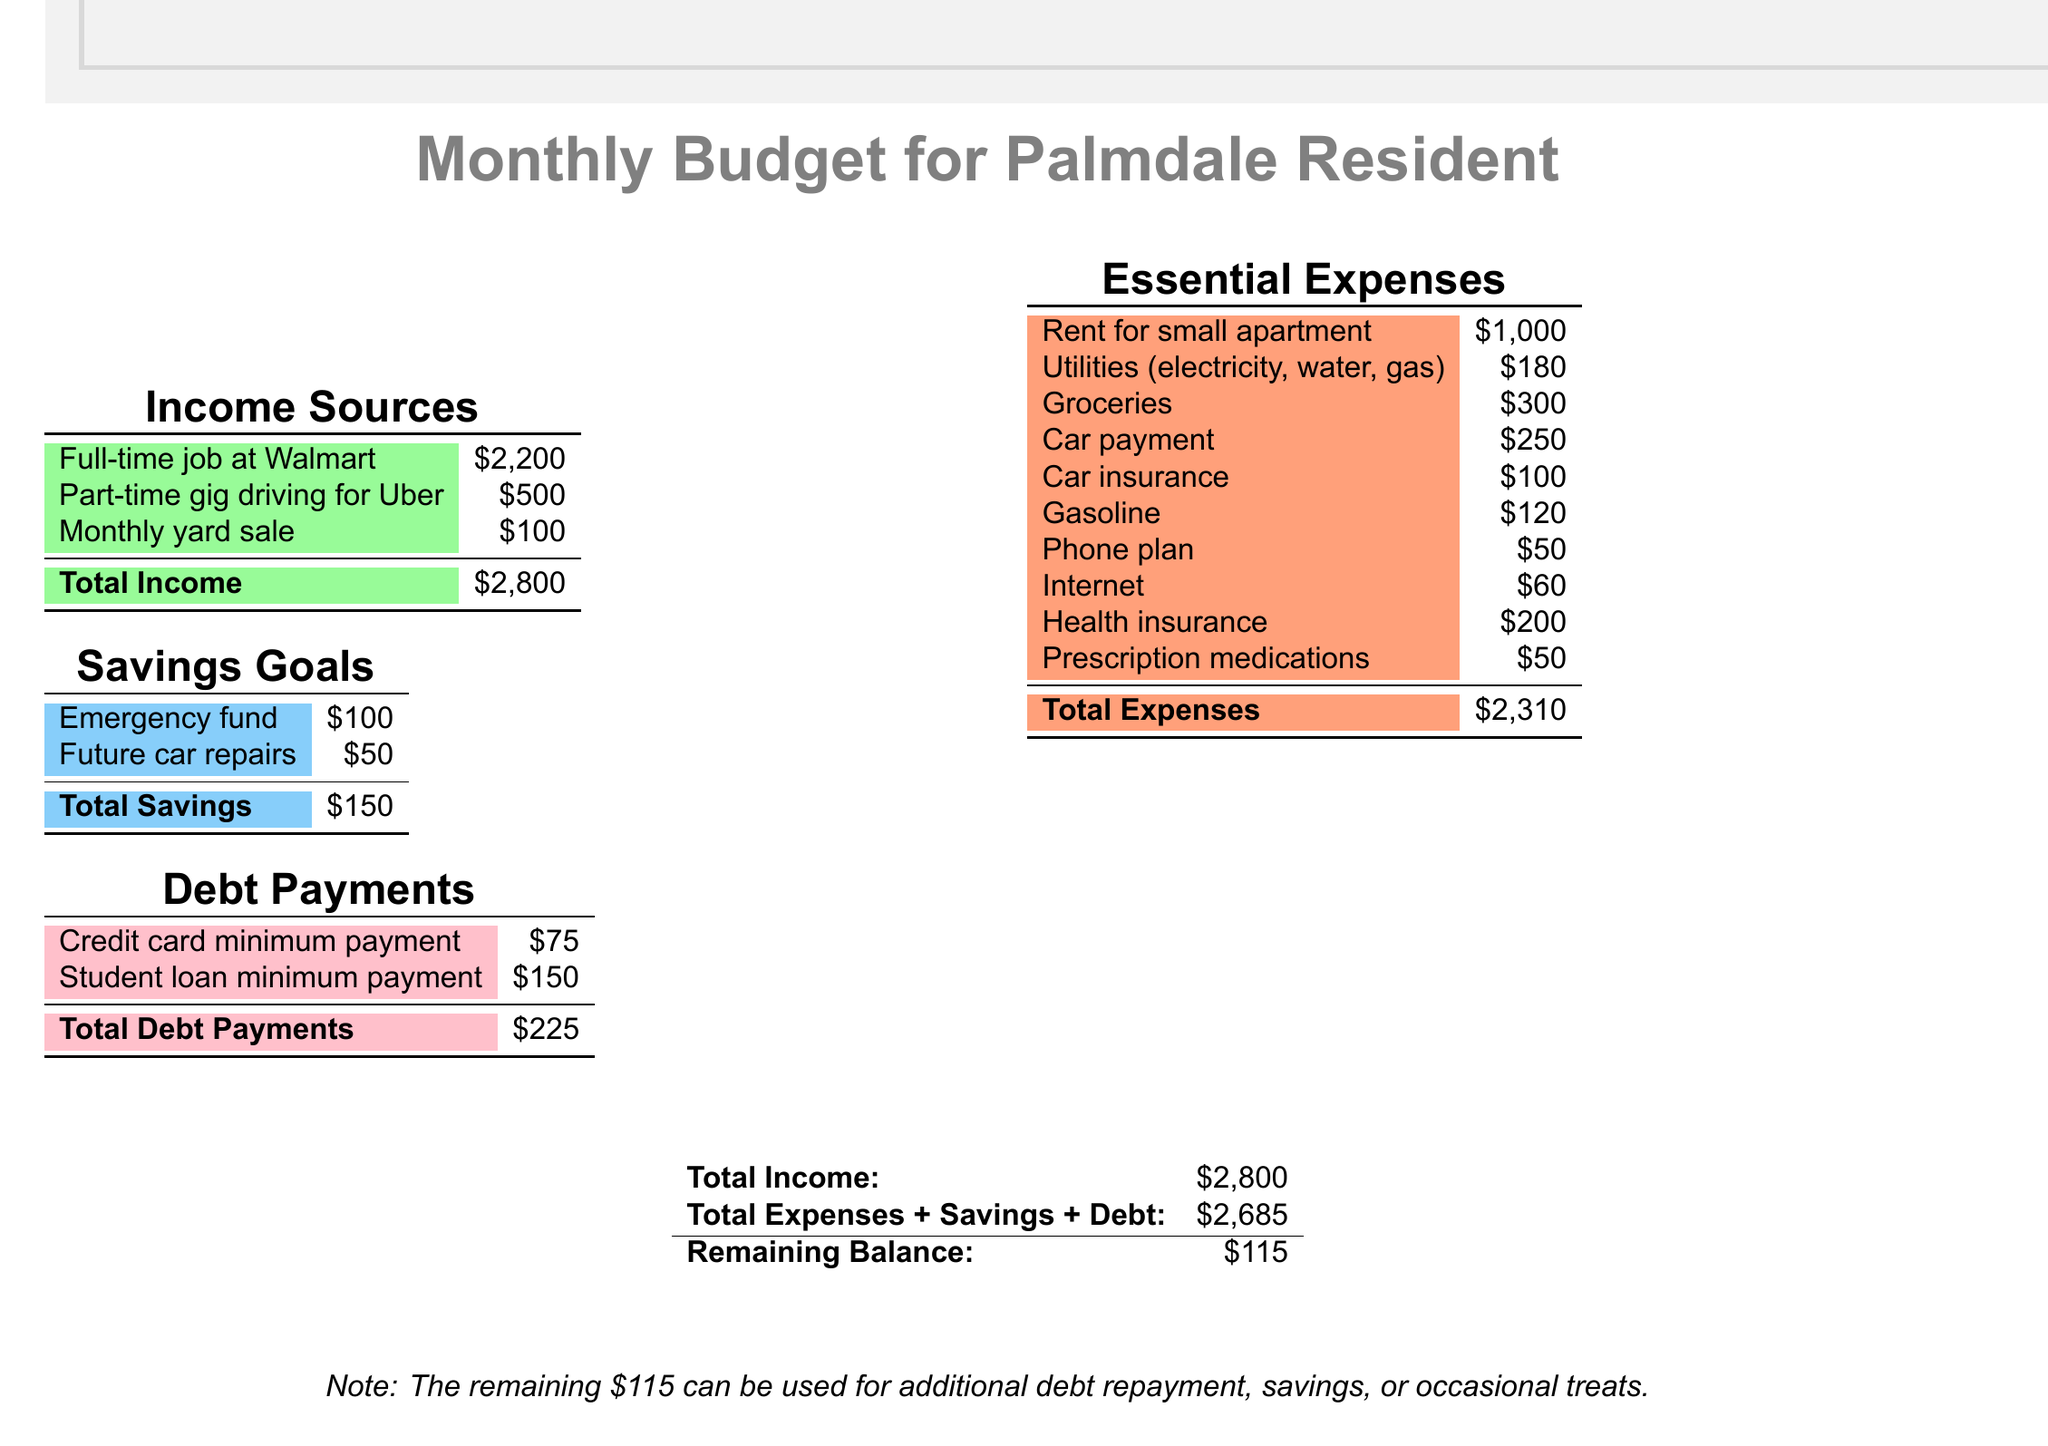What is the total income? The total income is provided at the bottom of the income section as the sum of all income sources, which totals to $2,800.
Answer: $2,800 How much do you spend on groceries? The document lists groceries as an essential expense with a specific amount of $300.
Answer: $300 What is the remaining balance after expenses, savings, and debt payments? The remaining balance is calculated by subtracting total expenses plus savings and debt from total income, resulting in $115.
Answer: $115 What is the amount for health insurance? Health insurance is categorized under essential expenses, with the specific amount listed as $200 in the document.
Answer: $200 What is the total debt payment? The total debt payment is the sum of the credit card and student loan payments, listed as $225 in the debt section.
Answer: $225 How much is allocated for the emergency fund? The document indicates that $100 is set aside for the emergency fund under the savings goals section.
Answer: $100 What is the cost of the car payment? The essential expenses section specifies the monthly car payment as $250.
Answer: $250 Which source provides the highest income? The highest income source mentioned is the full-time job at Walmart, which generates $2,200.
Answer: Full-time job at Walmart What is the total for essential expenses? The total essential expenses amount is calculated and provided at the bottom of the expenses section, equaling $2,310.
Answer: $2,310 How much is budgeted for future car repairs? In the savings goals section, it shows that $50 is allocated for future car repairs.
Answer: $50 